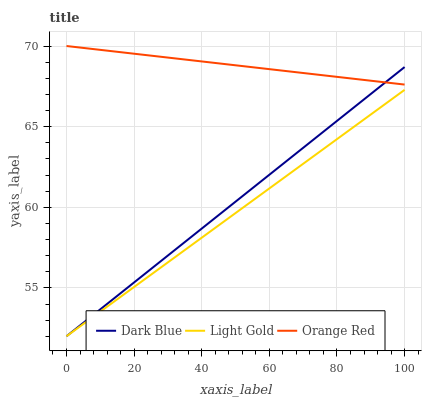Does Light Gold have the minimum area under the curve?
Answer yes or no. Yes. Does Orange Red have the maximum area under the curve?
Answer yes or no. Yes. Does Orange Red have the minimum area under the curve?
Answer yes or no. No. Does Light Gold have the maximum area under the curve?
Answer yes or no. No. Is Dark Blue the smoothest?
Answer yes or no. Yes. Is Orange Red the roughest?
Answer yes or no. Yes. Is Light Gold the smoothest?
Answer yes or no. No. Is Light Gold the roughest?
Answer yes or no. No. Does Dark Blue have the lowest value?
Answer yes or no. Yes. Does Orange Red have the lowest value?
Answer yes or no. No. Does Orange Red have the highest value?
Answer yes or no. Yes. Does Light Gold have the highest value?
Answer yes or no. No. Is Light Gold less than Orange Red?
Answer yes or no. Yes. Is Orange Red greater than Light Gold?
Answer yes or no. Yes. Does Dark Blue intersect Light Gold?
Answer yes or no. Yes. Is Dark Blue less than Light Gold?
Answer yes or no. No. Is Dark Blue greater than Light Gold?
Answer yes or no. No. Does Light Gold intersect Orange Red?
Answer yes or no. No. 